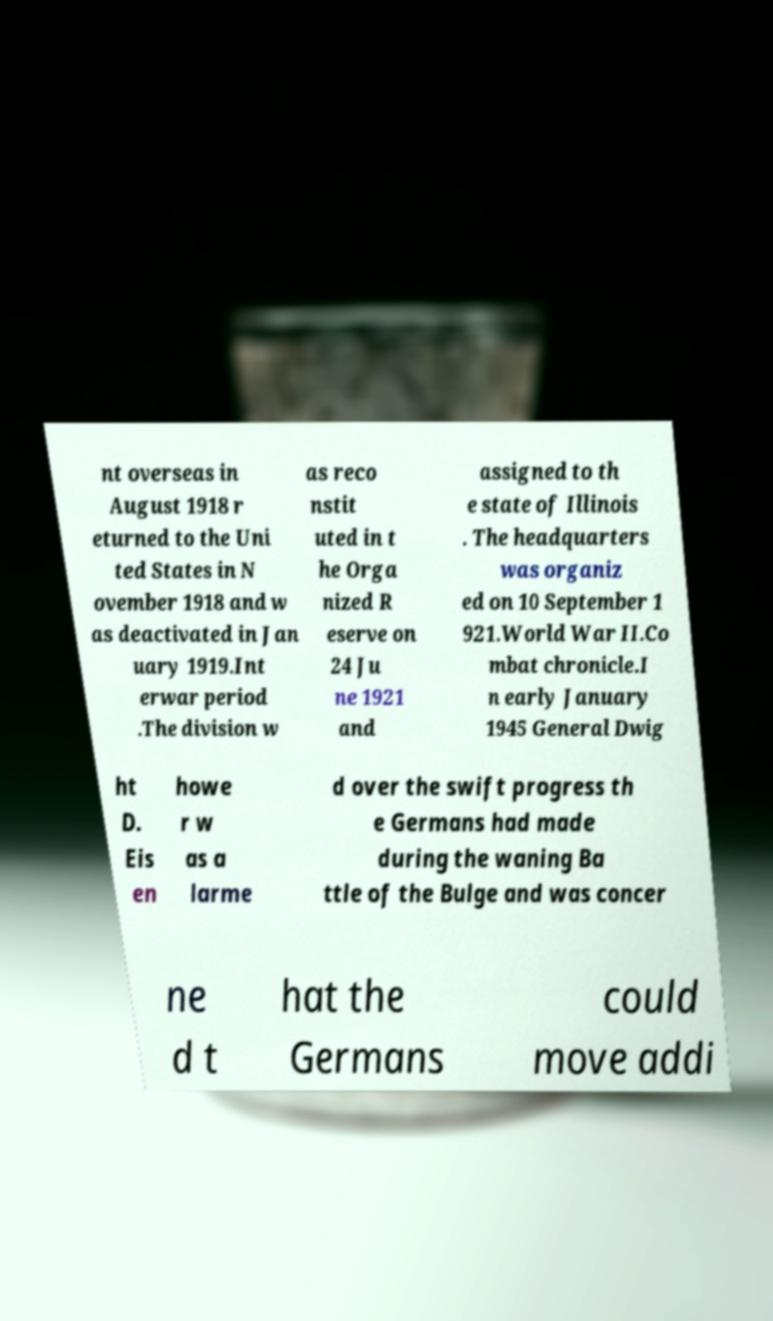For documentation purposes, I need the text within this image transcribed. Could you provide that? nt overseas in August 1918 r eturned to the Uni ted States in N ovember 1918 and w as deactivated in Jan uary 1919.Int erwar period .The division w as reco nstit uted in t he Orga nized R eserve on 24 Ju ne 1921 and assigned to th e state of Illinois . The headquarters was organiz ed on 10 September 1 921.World War II.Co mbat chronicle.I n early January 1945 General Dwig ht D. Eis en howe r w as a larme d over the swift progress th e Germans had made during the waning Ba ttle of the Bulge and was concer ne d t hat the Germans could move addi 